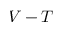Convert formula to latex. <formula><loc_0><loc_0><loc_500><loc_500>V - T</formula> 